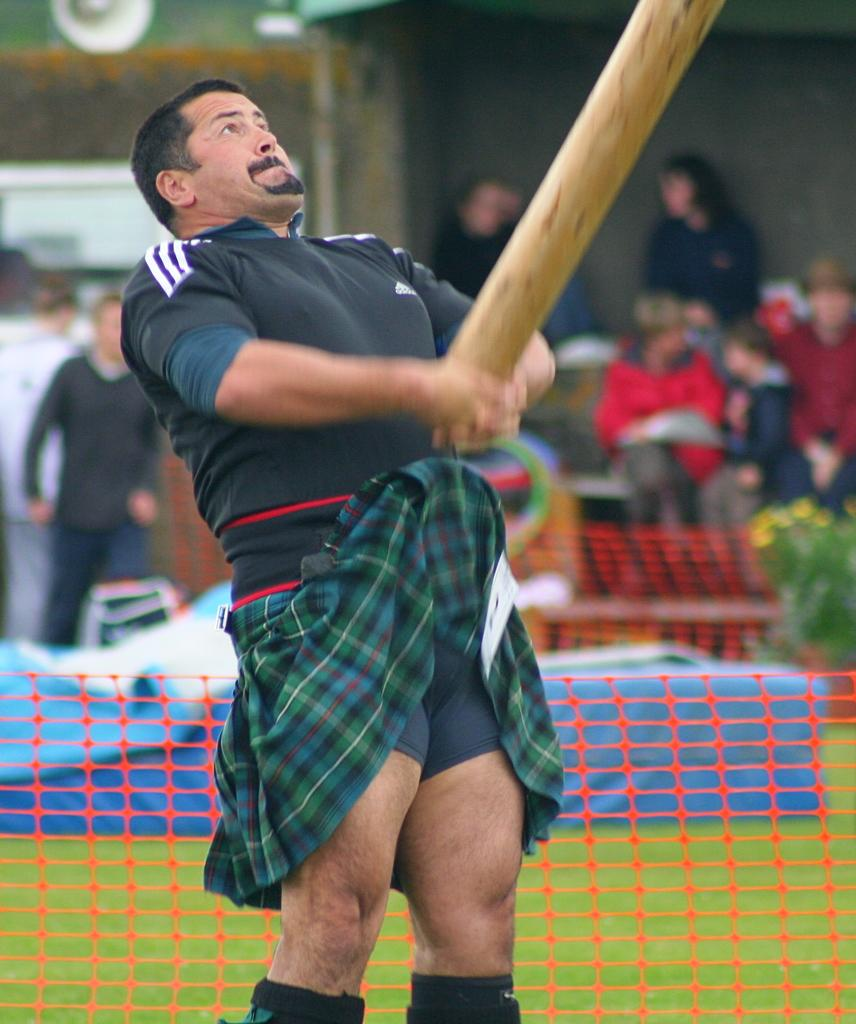Who is the main subject in the image? A: There is a man in the center of the image. What is the man holding in the image? The man is holding a wooden object. What can be seen in the background of the image? There is a fence, a plant, people, and a wall visible behind the fence. What type of ground is visible behind the fence? The ground is visible behind the fence, but the type of ground cannot be determined from the image. Is there a list of items for sale hanging on the wall behind the fence? There is no list of items for sale visible in the image. 